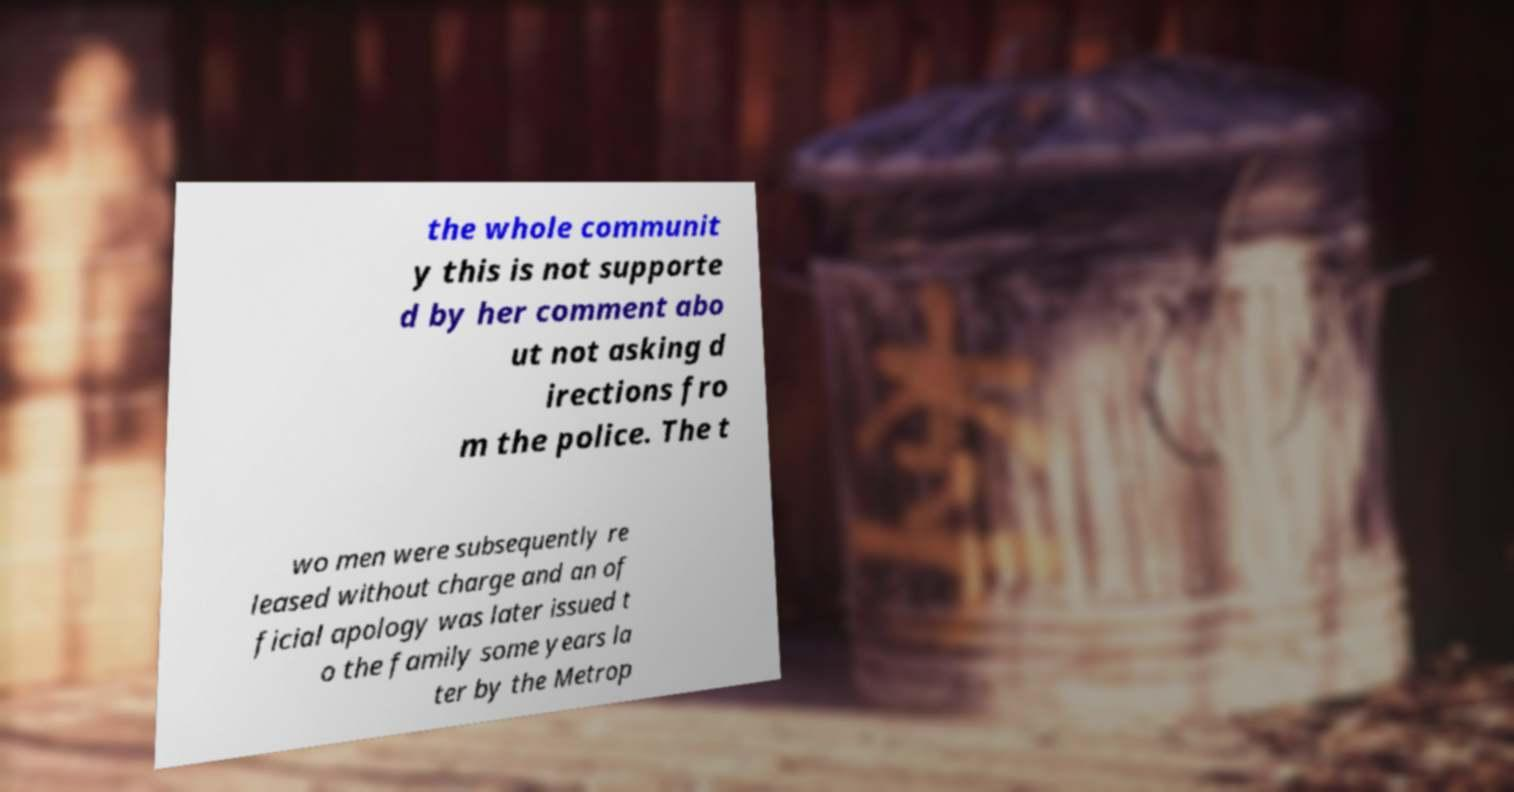I need the written content from this picture converted into text. Can you do that? the whole communit y this is not supporte d by her comment abo ut not asking d irections fro m the police. The t wo men were subsequently re leased without charge and an of ficial apology was later issued t o the family some years la ter by the Metrop 